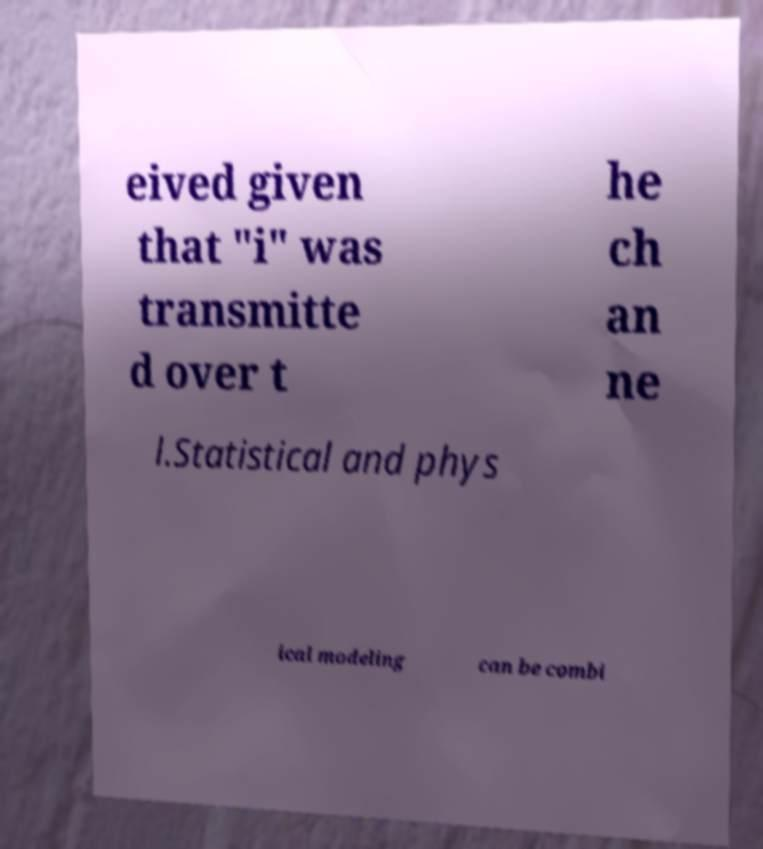Could you extract and type out the text from this image? eived given that "i" was transmitte d over t he ch an ne l.Statistical and phys ical modeling can be combi 